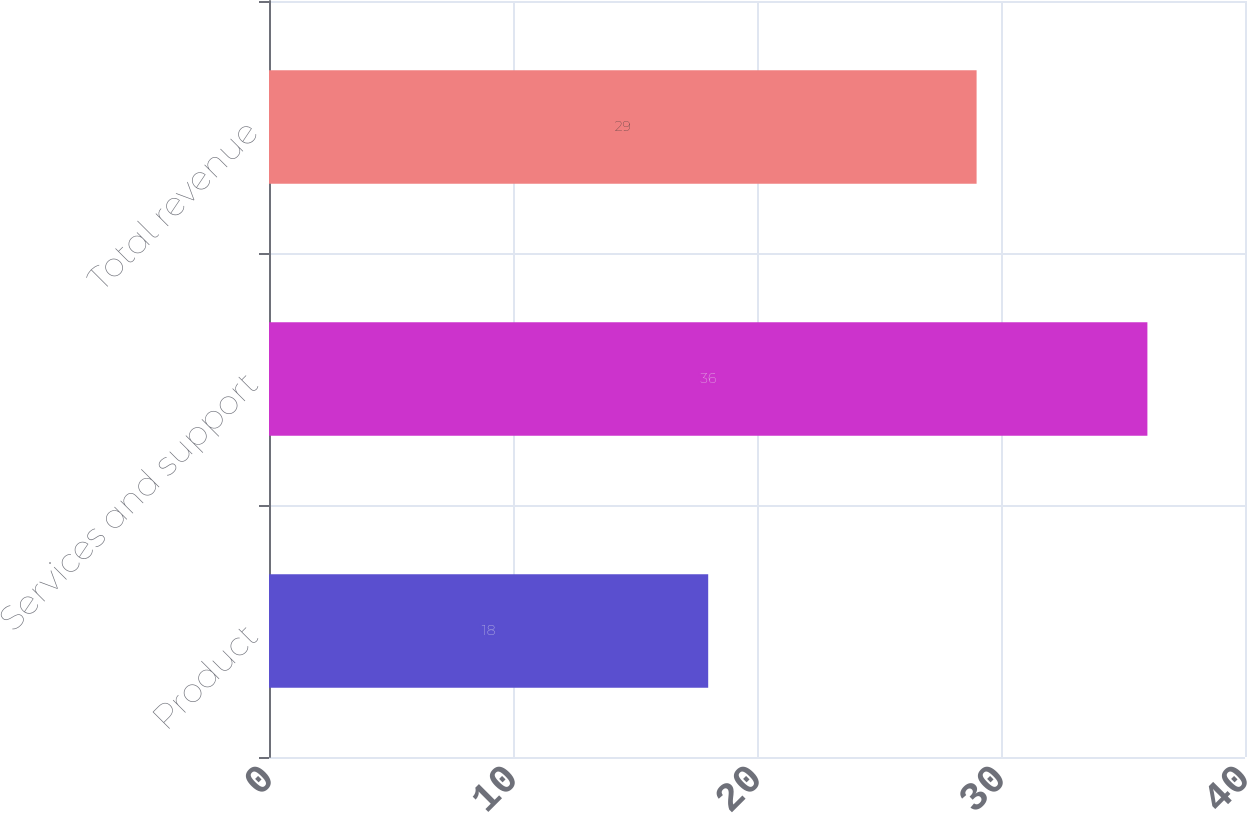<chart> <loc_0><loc_0><loc_500><loc_500><bar_chart><fcel>Product<fcel>Services and support<fcel>Total revenue<nl><fcel>18<fcel>36<fcel>29<nl></chart> 